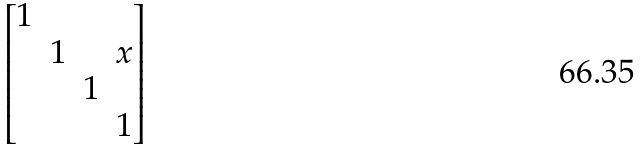Convert formula to latex. <formula><loc_0><loc_0><loc_500><loc_500>\begin{bmatrix} 1 & & & \\ & 1 & & x \\ & & 1 & \\ & & & 1 \end{bmatrix}</formula> 